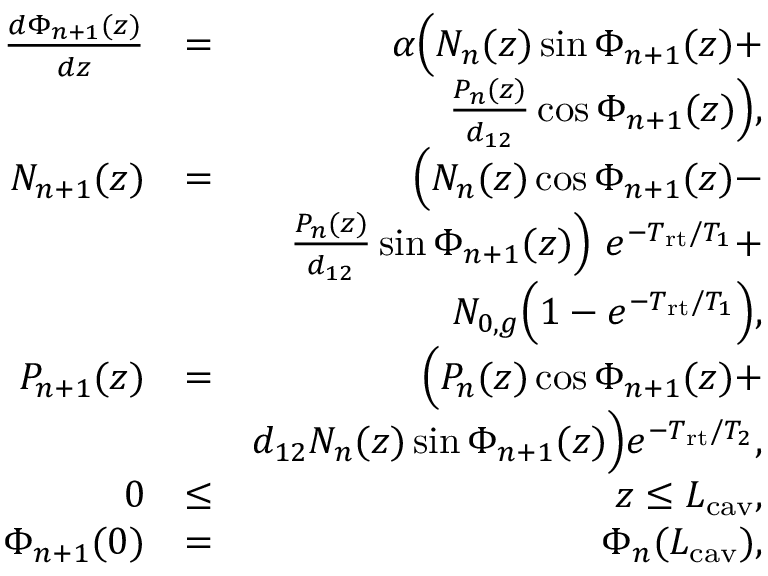<formula> <loc_0><loc_0><loc_500><loc_500>\begin{array} { r l r } { \frac { d \Phi _ { n + 1 } ( z ) } { d z } } & { = } & { \alpha \left ( N _ { n } ( z ) \sin \Phi _ { n + 1 } ( z ) + } \\ & { \frac { P _ { n } ( z ) } { d _ { 1 2 } } \cos \Phi _ { n + 1 } ( z ) \right ) , } \\ { N _ { n + 1 } ( z ) } & { = } & { \left ( N _ { n } ( z ) \cos \Phi _ { n + 1 } ( z ) - } \\ & { \frac { P _ { n } ( z ) } { d _ { 1 2 } } \sin \Phi _ { n + 1 } ( z ) \right ) \ e ^ { - T _ { r t } / T _ { 1 } } + } \\ & { N _ { 0 , g } \left ( 1 - e ^ { - T _ { r t } / T _ { 1 } } \right ) , } \\ { P _ { n + 1 } ( z ) } & { = } & { \left ( P _ { n } ( z ) \cos \Phi _ { n + 1 } ( z ) + } \\ & { d _ { 1 2 } N _ { n } ( z ) \sin \Phi _ { n + 1 } ( z ) \right ) e ^ { - T _ { r t } / T _ { 2 } } , } \\ { 0 } & { \leq } & { z \leq L _ { c a v } , } \\ { \Phi _ { n + 1 } ( 0 ) } & { = } & { \Phi _ { n } ( L _ { c a v } ) , } \end{array}</formula> 